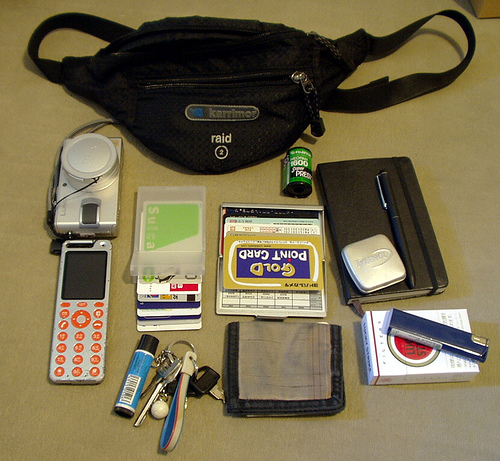<image>
Is there a pen in the diary? No. The pen is not contained within the diary. These objects have a different spatial relationship. Where is the camera in relation to the bag? Is it in the bag? No. The camera is not contained within the bag. These objects have a different spatial relationship. 